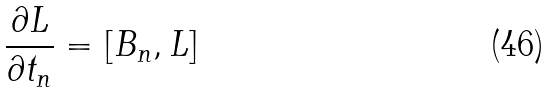<formula> <loc_0><loc_0><loc_500><loc_500>\frac { \partial L } { \partial t _ { n } } = [ B _ { n } , L ]</formula> 